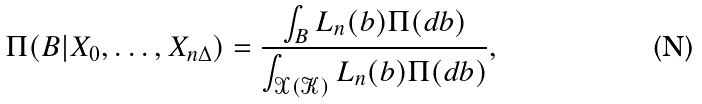<formula> <loc_0><loc_0><loc_500><loc_500>\Pi ( B | X _ { 0 } , \dots , X _ { n \Delta } ) = \frac { \int _ { B } L _ { n } ( b ) \Pi ( d b ) } { \int _ { \mathcal { X ( K ) } } L _ { n } ( b ) \Pi ( d b ) } ,</formula> 